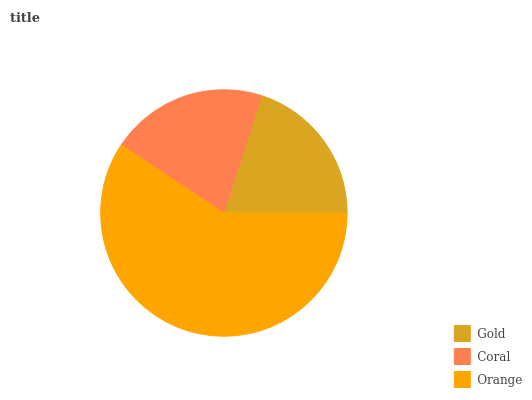Is Gold the minimum?
Answer yes or no. Yes. Is Orange the maximum?
Answer yes or no. Yes. Is Coral the minimum?
Answer yes or no. No. Is Coral the maximum?
Answer yes or no. No. Is Coral greater than Gold?
Answer yes or no. Yes. Is Gold less than Coral?
Answer yes or no. Yes. Is Gold greater than Coral?
Answer yes or no. No. Is Coral less than Gold?
Answer yes or no. No. Is Coral the high median?
Answer yes or no. Yes. Is Coral the low median?
Answer yes or no. Yes. Is Orange the high median?
Answer yes or no. No. Is Orange the low median?
Answer yes or no. No. 